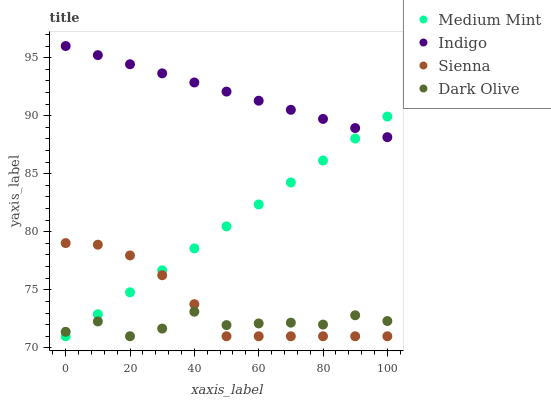Does Dark Olive have the minimum area under the curve?
Answer yes or no. Yes. Does Indigo have the maximum area under the curve?
Answer yes or no. Yes. Does Sienna have the minimum area under the curve?
Answer yes or no. No. Does Sienna have the maximum area under the curve?
Answer yes or no. No. Is Medium Mint the smoothest?
Answer yes or no. Yes. Is Dark Olive the roughest?
Answer yes or no. Yes. Is Sienna the smoothest?
Answer yes or no. No. Is Sienna the roughest?
Answer yes or no. No. Does Medium Mint have the lowest value?
Answer yes or no. Yes. Does Indigo have the lowest value?
Answer yes or no. No. Does Indigo have the highest value?
Answer yes or no. Yes. Does Sienna have the highest value?
Answer yes or no. No. Is Sienna less than Indigo?
Answer yes or no. Yes. Is Indigo greater than Sienna?
Answer yes or no. Yes. Does Medium Mint intersect Dark Olive?
Answer yes or no. Yes. Is Medium Mint less than Dark Olive?
Answer yes or no. No. Is Medium Mint greater than Dark Olive?
Answer yes or no. No. Does Sienna intersect Indigo?
Answer yes or no. No. 